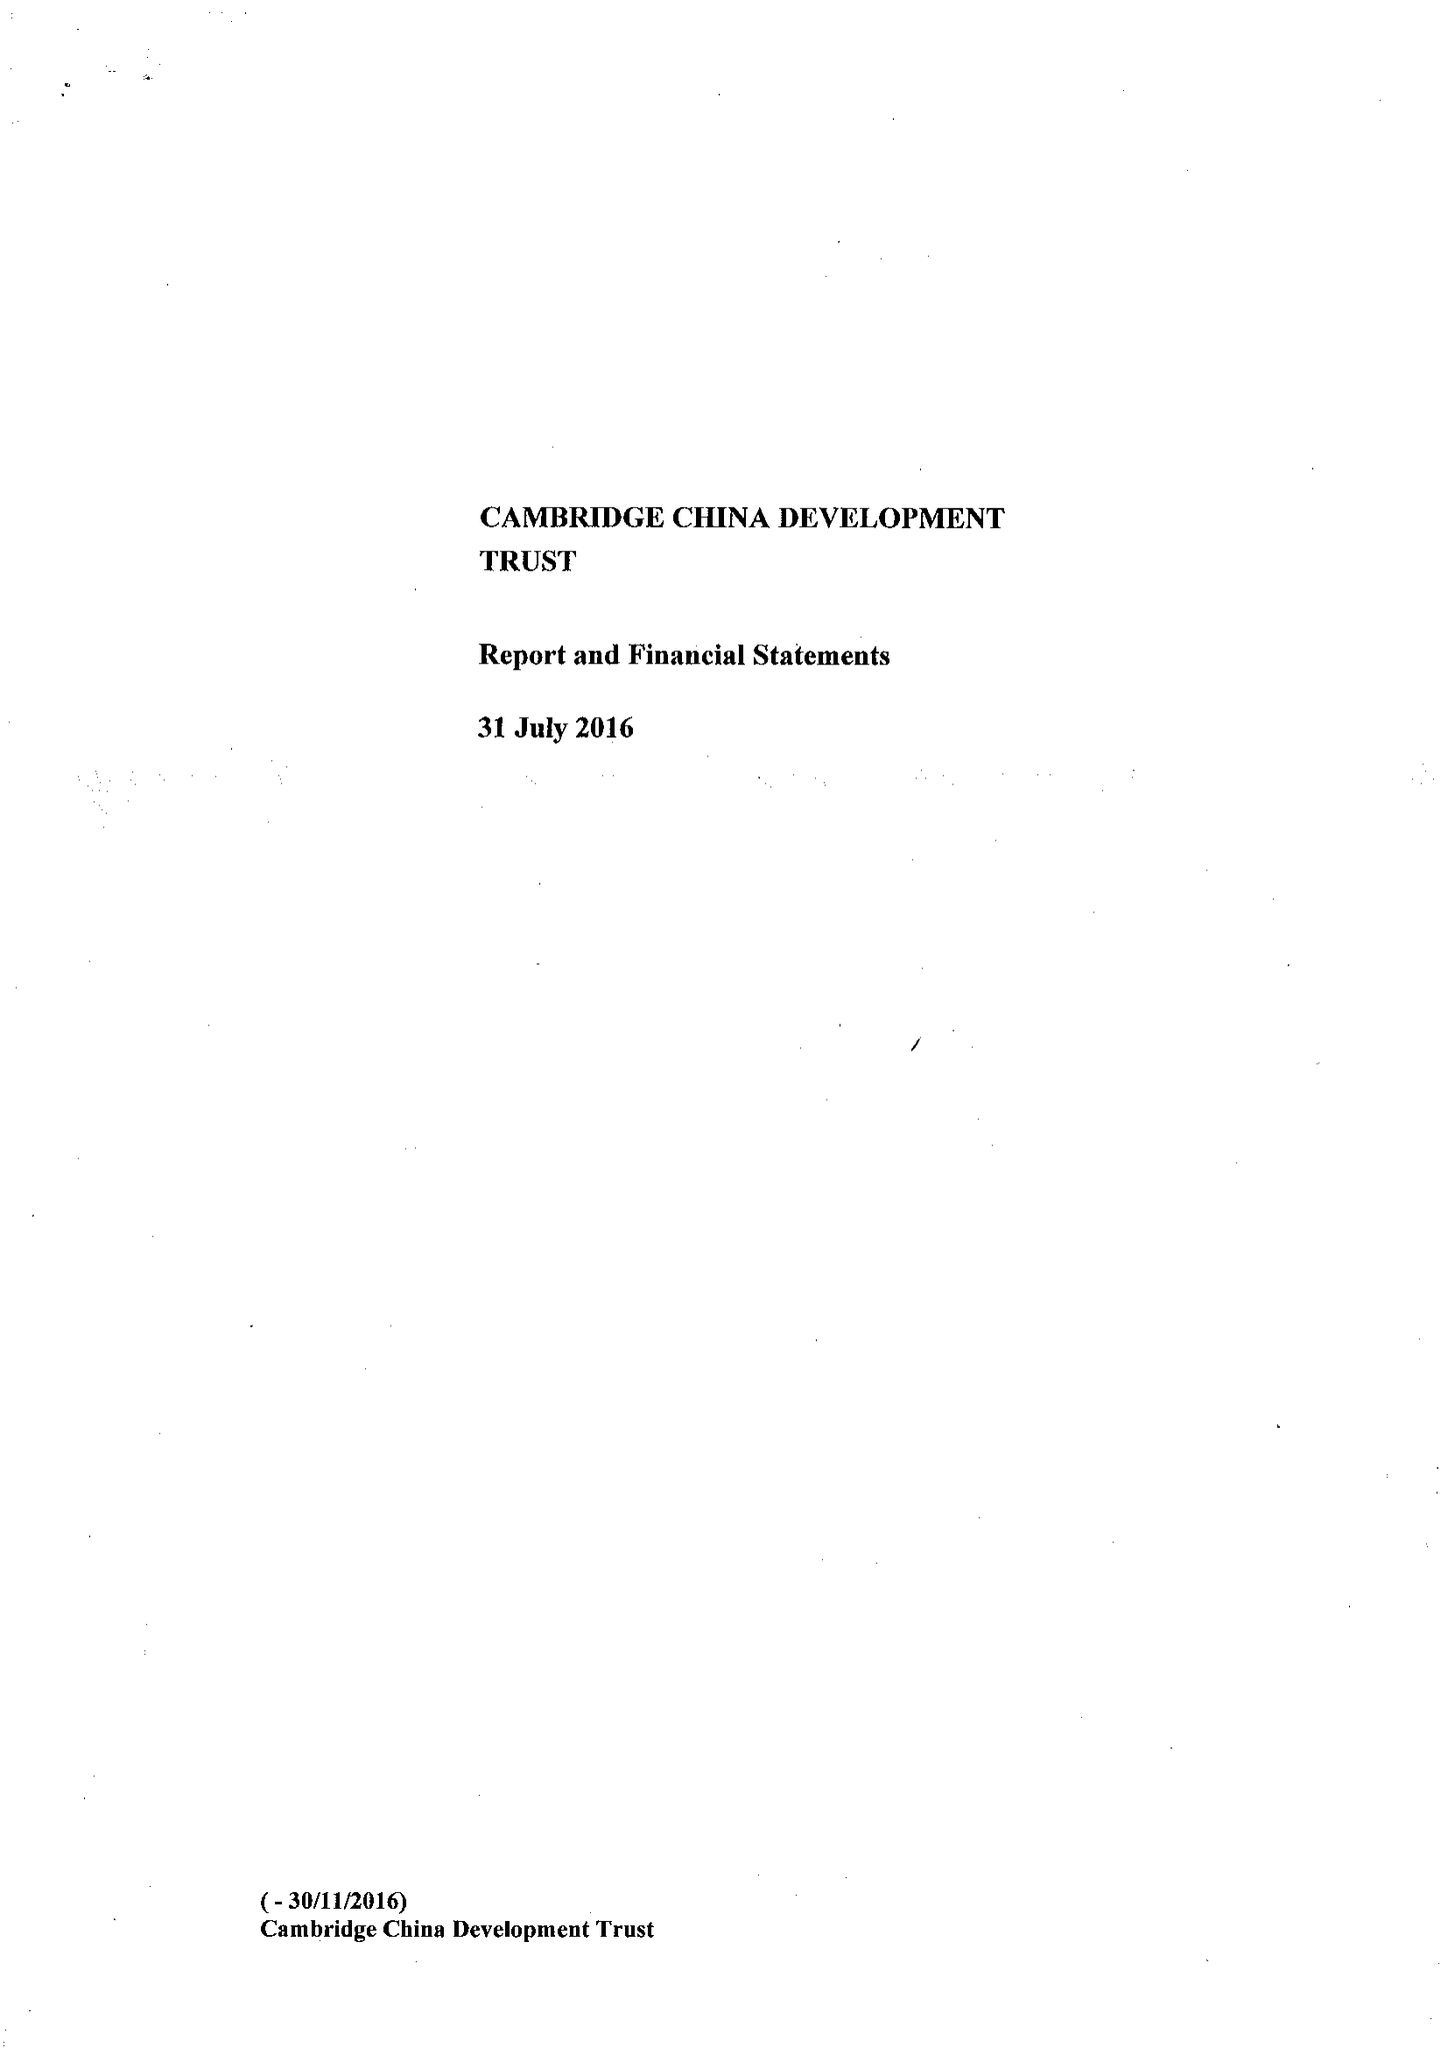What is the value for the income_annually_in_british_pounds?
Answer the question using a single word or phrase. 611619.00 